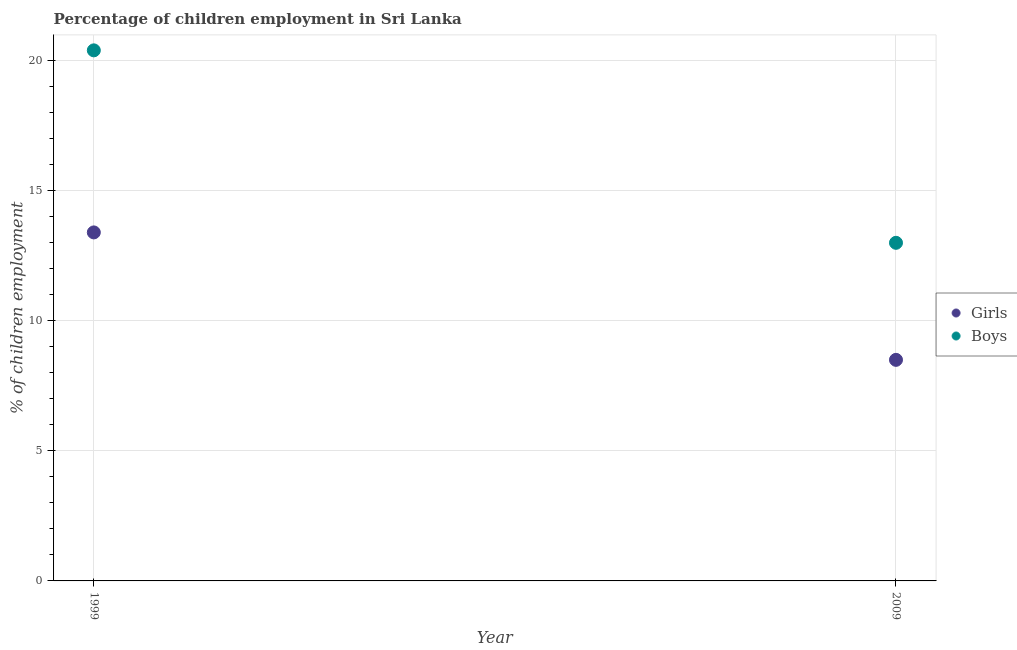What is the percentage of employed boys in 2009?
Your answer should be compact. 13. Across all years, what is the minimum percentage of employed girls?
Make the answer very short. 8.5. In which year was the percentage of employed girls maximum?
Your response must be concise. 1999. In which year was the percentage of employed boys minimum?
Your answer should be very brief. 2009. What is the total percentage of employed girls in the graph?
Keep it short and to the point. 21.9. What is the difference between the percentage of employed boys in 1999 and the percentage of employed girls in 2009?
Keep it short and to the point. 11.9. What is the average percentage of employed girls per year?
Give a very brief answer. 10.95. In how many years, is the percentage of employed boys greater than 18 %?
Keep it short and to the point. 1. What is the ratio of the percentage of employed boys in 1999 to that in 2009?
Provide a short and direct response. 1.57. Is the percentage of employed girls in 1999 less than that in 2009?
Make the answer very short. No. In how many years, is the percentage of employed girls greater than the average percentage of employed girls taken over all years?
Your response must be concise. 1. Does the percentage of employed boys monotonically increase over the years?
Your answer should be very brief. No. How many dotlines are there?
Keep it short and to the point. 2. How many years are there in the graph?
Your answer should be compact. 2. What is the difference between two consecutive major ticks on the Y-axis?
Your answer should be very brief. 5. Does the graph contain any zero values?
Ensure brevity in your answer.  No. Does the graph contain grids?
Offer a terse response. Yes. Where does the legend appear in the graph?
Your response must be concise. Center right. How many legend labels are there?
Give a very brief answer. 2. What is the title of the graph?
Your answer should be very brief. Percentage of children employment in Sri Lanka. What is the label or title of the X-axis?
Your answer should be compact. Year. What is the label or title of the Y-axis?
Give a very brief answer. % of children employment. What is the % of children employment in Boys in 1999?
Ensure brevity in your answer.  20.4. What is the % of children employment in Girls in 2009?
Provide a short and direct response. 8.5. What is the % of children employment of Boys in 2009?
Provide a short and direct response. 13. Across all years, what is the maximum % of children employment in Boys?
Provide a succinct answer. 20.4. What is the total % of children employment in Girls in the graph?
Your answer should be compact. 21.9. What is the total % of children employment of Boys in the graph?
Provide a succinct answer. 33.4. What is the difference between the % of children employment of Girls in 1999 and that in 2009?
Offer a terse response. 4.9. What is the average % of children employment of Girls per year?
Provide a short and direct response. 10.95. In the year 1999, what is the difference between the % of children employment of Girls and % of children employment of Boys?
Your answer should be very brief. -7. What is the ratio of the % of children employment in Girls in 1999 to that in 2009?
Offer a very short reply. 1.58. What is the ratio of the % of children employment in Boys in 1999 to that in 2009?
Keep it short and to the point. 1.57. What is the difference between the highest and the second highest % of children employment in Girls?
Your answer should be very brief. 4.9. What is the difference between the highest and the second highest % of children employment of Boys?
Provide a short and direct response. 7.4. What is the difference between the highest and the lowest % of children employment of Boys?
Your answer should be very brief. 7.4. 